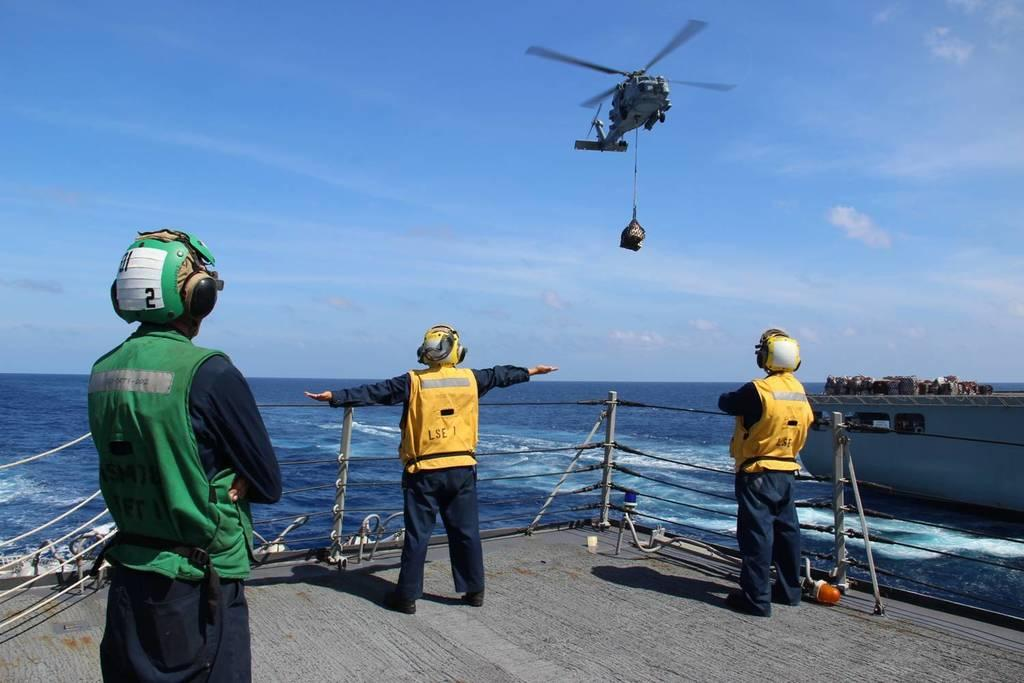How many people are in the image? There are three people standing in the center of the image. What is happening in the sky in the image? There is an aeroplane flying in the sky. What can be seen in the background of the image? There is a sea and rocks in the background of the image. What type of committee is responsible for the rocks in the image? There is no committee mentioned or implied in the image, and the rocks are a natural part of the landscape. 